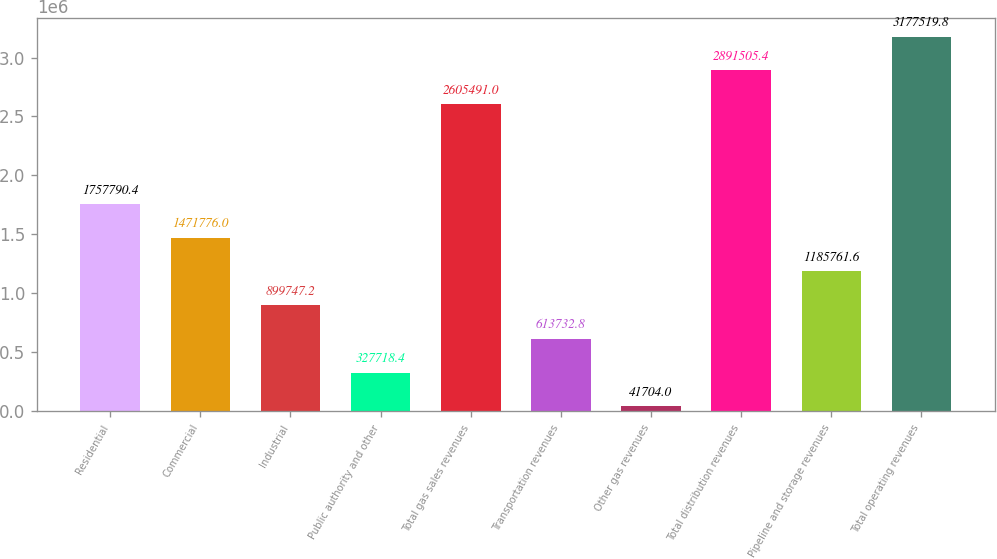Convert chart to OTSL. <chart><loc_0><loc_0><loc_500><loc_500><bar_chart><fcel>Residential<fcel>Commercial<fcel>Industrial<fcel>Public authority and other<fcel>Total gas sales revenues<fcel>Transportation revenues<fcel>Other gas revenues<fcel>Total distribution revenues<fcel>Pipeline and storage revenues<fcel>Total operating revenues<nl><fcel>1.75779e+06<fcel>1.47178e+06<fcel>899747<fcel>327718<fcel>2.60549e+06<fcel>613733<fcel>41704<fcel>2.89151e+06<fcel>1.18576e+06<fcel>3.17752e+06<nl></chart> 